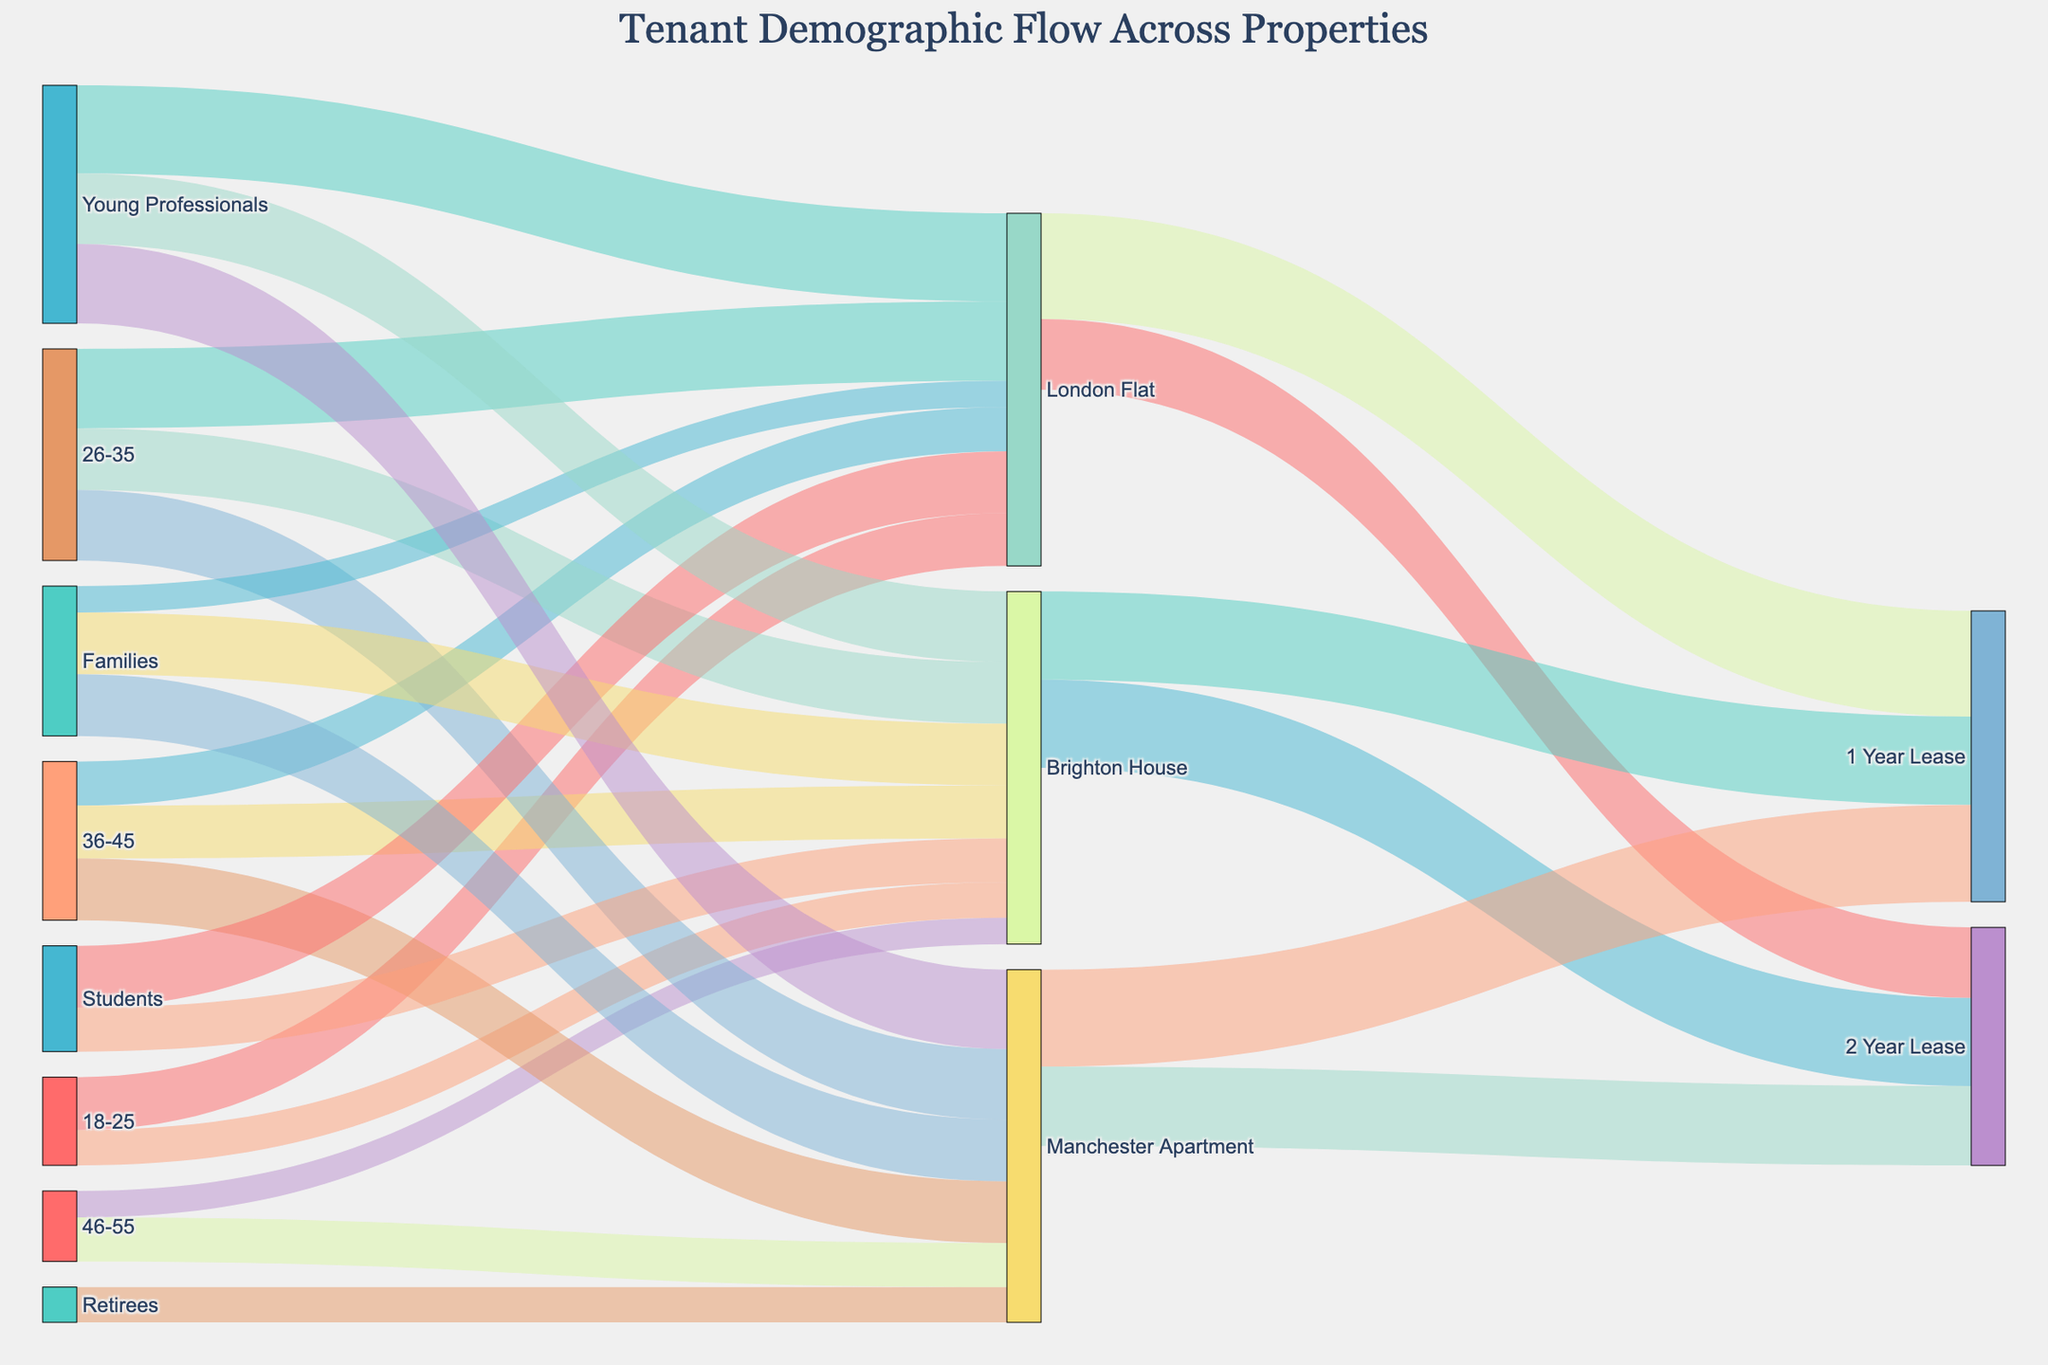What is the title of the diagram? The title is located at the top center of the figure. It helps to understand what the diagram is about. The title states “Tenant Demographic Flow Across Properties.”
Answer: Tenant Demographic Flow Across Properties How many tenants aged between 26-35 live in the Brighton House? You need to find the value associated with the 26-35 age group targeting the Brighton House. According to the data, this value is 35.
Answer: 35 What percentage of the tenants in the London Flat have leases of 2 years? First, find the total number of tenants in the London Flat by summing up all the flows into the lease categories (60 for 1 Year Lease and 40 for 2 Year Lease). The total is 100. To find the percentage, take the number of tenants with a 2-year lease (40) divided by the total number of tenants (100), then multiply by 100%. The percentage is \( 40/100 \times 100\% = 40\% \).
Answer: 40% Which property has a higher number of retirees, Manchester Apartment or Brighton House? Look at the data points related to retirees and compare the value. Manchester Apartment has 20 retirees, while Brighton House has none listed.
Answer: Manchester Apartment How many Young Professionals live in the London Flat and Manchester Apartment combined? You need to sum the numbers for Young Professionals in both properties. London Flat has 50, and Manchester Apartment has 45 Young Professionals. So, the combined total is \(50 + 45 = 95\).
Answer: 95 What is the total number of tenants living in the Brighton House? Add all the tenant numbers living in Brighton House from all age groups (20 + 35 + 30 + 15) and all professions (25 + 40 + 35). Then sum them all together: \(20 + 35 + 30 + 15 + 25 + 40 + 35 = 200\).
Answer: 200 Which age group contributes most to the tenants living in the London Flat? Compare the values for each age group’s contribution to the London Flat. The highest value among 18-25 (30), 26-35 (45), and 36-45 (25) is 45 for the 26-35 age group.
Answer: 26-35 For tenants with a 1-year lease, which property has the highest number of tenants? Compare the numbers of tenants with a 1-year lease across all properties (London Flat: 60, Brighton House: 50, Manchester Apartment: 55). The highest number, 60, is associated with the London Flat.
Answer: London Flat Which profession has the least tenants in the Brighton House? Look at the profession-related flows targeting Brighton House and find the lowest value (Students: 25, Young Professionals: 40, Families: 35). The least number is 25, referring to Students.
Answer: Students 